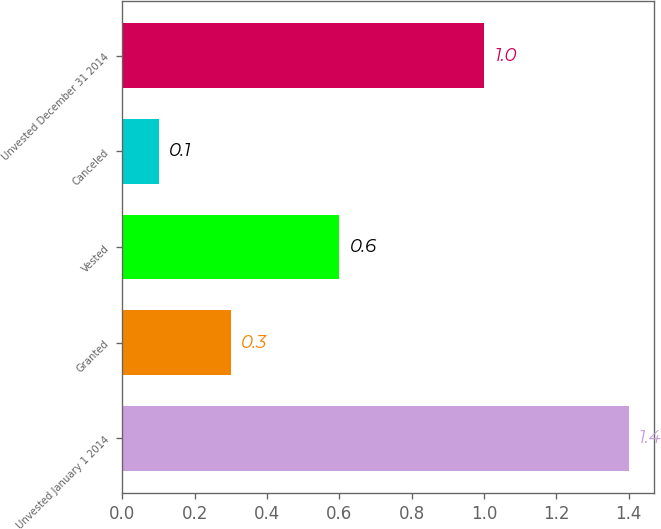Convert chart. <chart><loc_0><loc_0><loc_500><loc_500><bar_chart><fcel>Unvested January 1 2014<fcel>Granted<fcel>Vested<fcel>Canceled<fcel>Unvested December 31 2014<nl><fcel>1.4<fcel>0.3<fcel>0.6<fcel>0.1<fcel>1<nl></chart> 